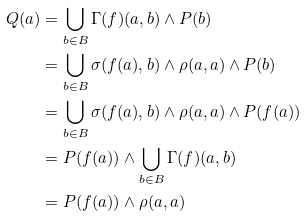<formula> <loc_0><loc_0><loc_500><loc_500>Q ( a ) & = \bigcup _ { b \in B } \Gamma ( f ) ( a , b ) \wedge P ( b ) \\ & = \bigcup _ { b \in B } \sigma ( f ( a ) , b ) \wedge \rho ( a , a ) \wedge P ( b ) \\ & = \bigcup _ { b \in B } \sigma ( f ( a ) , b ) \wedge \rho ( a , a ) \wedge P ( f ( a ) ) \\ & = P ( f ( a ) ) \wedge \bigcup _ { b \in B } \Gamma ( f ) ( a , b ) \\ & = P ( f ( a ) ) \wedge \rho ( a , a )</formula> 